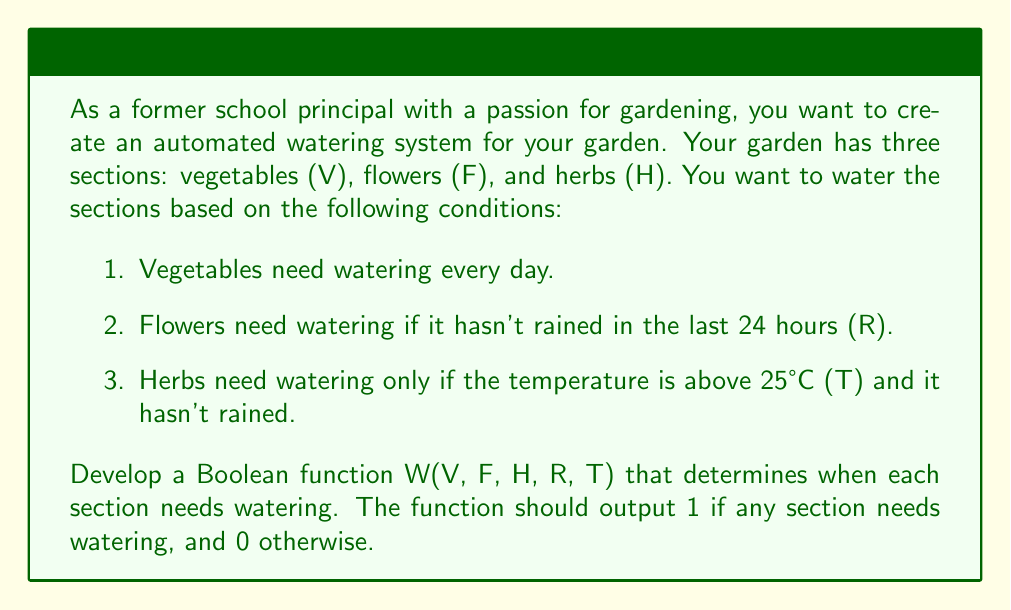Solve this math problem. Let's approach this step-by-step:

1. First, we need to define our variables:
   V: Vegetables section
   F: Flowers section
   H: Herbs section
   R: It has rained in the last 24 hours (1 if true, 0 if false)
   T: Temperature is above 25°C (1 if true, 0 if false)

2. Now, let's consider each section:
   - Vegetables (V): Always need watering, so this is always 1.
   - Flowers (F): Need watering if it hasn't rained, so this is $F \cdot \overline{R}$
   - Herbs (H): Need watering if it's hot and hasn't rained, so this is $H \cdot T \cdot \overline{R}$

3. The overall function W will be true (1) if any of these conditions are true. We can represent this using the OR operation:

   $$W(V, F, H, R, T) = V + F \cdot \overline{R} + H \cdot T \cdot \overline{R}$$

4. This can be simplified slightly:

   $$W(V, F, H, R, T) = V + \overline{R} \cdot (F + H \cdot T)$$

This Boolean function will output 1 if any section needs watering, and 0 otherwise.
Answer: $$W(V, F, H, R, T) = V + \overline{R} \cdot (F + H \cdot T)$$ 